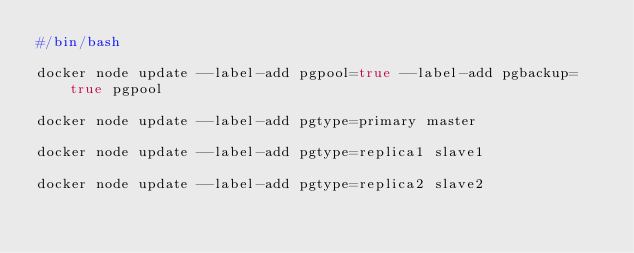Convert code to text. <code><loc_0><loc_0><loc_500><loc_500><_Bash_>#/bin/bash

docker node update --label-add pgpool=true --label-add pgbackup=true pgpool

docker node update --label-add pgtype=primary master

docker node update --label-add pgtype=replica1 slave1

docker node update --label-add pgtype=replica2 slave2
</code> 